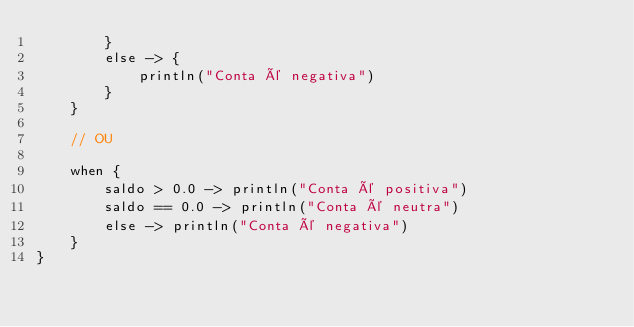Convert code to text. <code><loc_0><loc_0><loc_500><loc_500><_Kotlin_>        }
        else -> {
            println("Conta é negativa")
        }
    }

    // OU

    when {
        saldo > 0.0 -> println("Conta é positiva")
        saldo == 0.0 -> println("Conta é neutra")
        else -> println("Conta é negativa")
    }
}</code> 